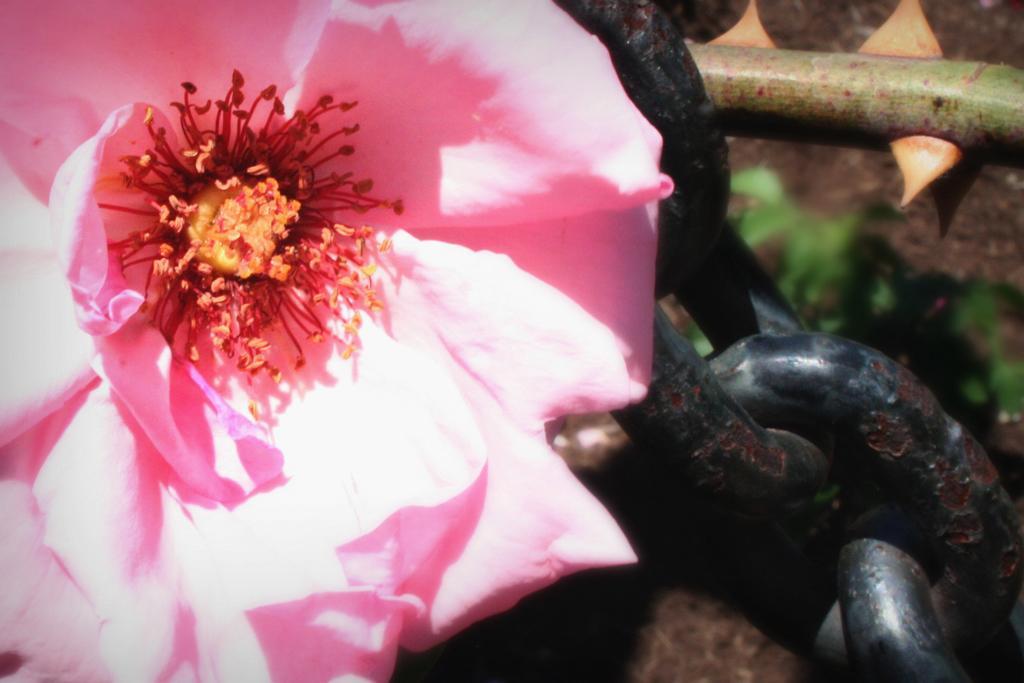Can you describe this image briefly? In this picture we can see a flower and links of a chain. 